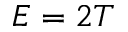Convert formula to latex. <formula><loc_0><loc_0><loc_500><loc_500>E = 2 T</formula> 